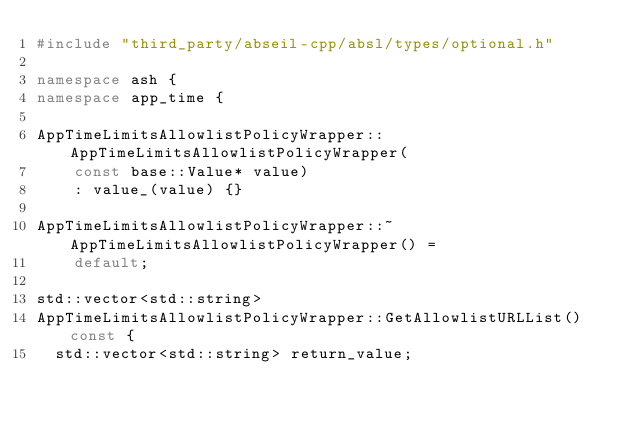<code> <loc_0><loc_0><loc_500><loc_500><_C++_>#include "third_party/abseil-cpp/absl/types/optional.h"

namespace ash {
namespace app_time {

AppTimeLimitsAllowlistPolicyWrapper::AppTimeLimitsAllowlistPolicyWrapper(
    const base::Value* value)
    : value_(value) {}

AppTimeLimitsAllowlistPolicyWrapper::~AppTimeLimitsAllowlistPolicyWrapper() =
    default;

std::vector<std::string>
AppTimeLimitsAllowlistPolicyWrapper::GetAllowlistURLList() const {
  std::vector<std::string> return_value;
</code> 